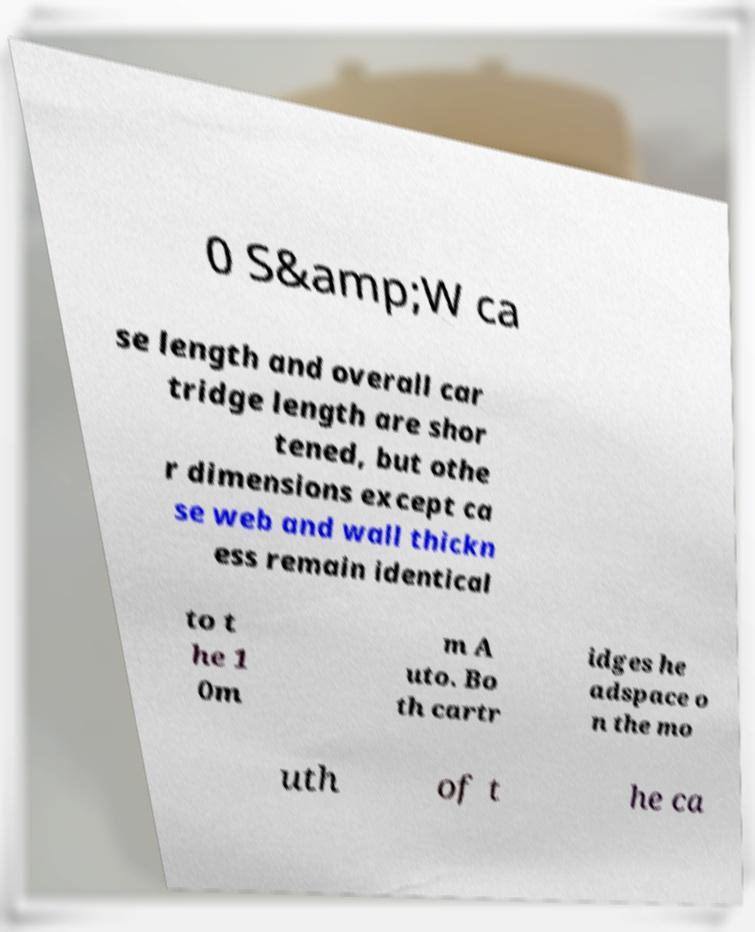Could you extract and type out the text from this image? 0 S&amp;W ca se length and overall car tridge length are shor tened, but othe r dimensions except ca se web and wall thickn ess remain identical to t he 1 0m m A uto. Bo th cartr idges he adspace o n the mo uth of t he ca 